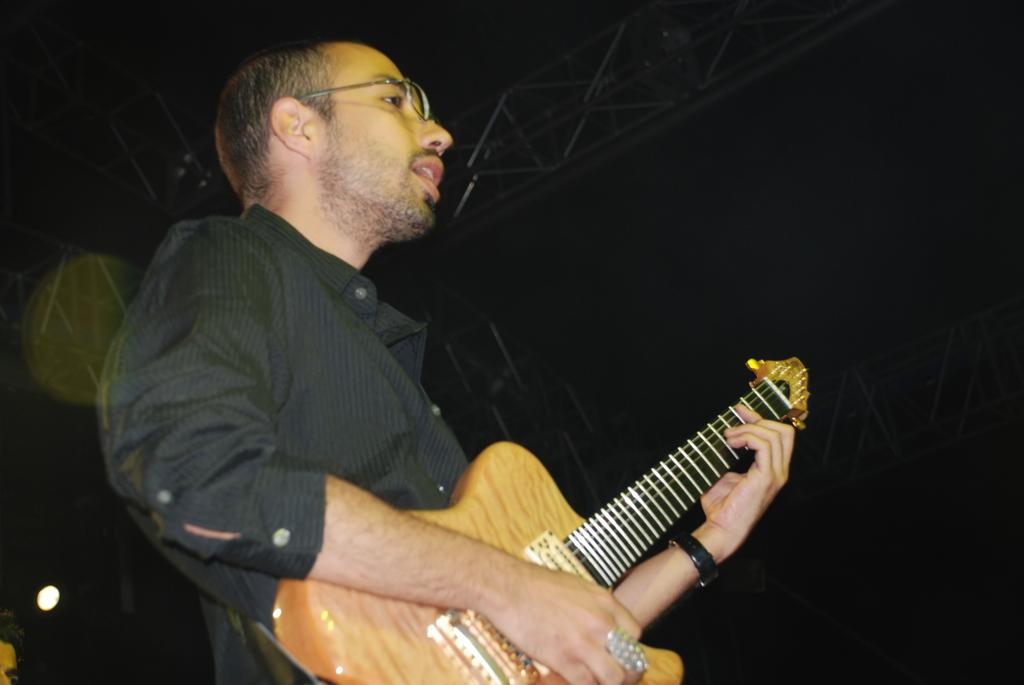What is the man in the image doing? The man is playing a guitar in the image. What accessory is the man wearing in the image? The man is wearing spectacles in the image. Can you describe the lighting in the image? The image appears to be well-lit. Where is the garden located in the image? There is no garden present in the image. What is the man trying to stop in the image? There is no indication in the image that the man is trying to stop anything. 